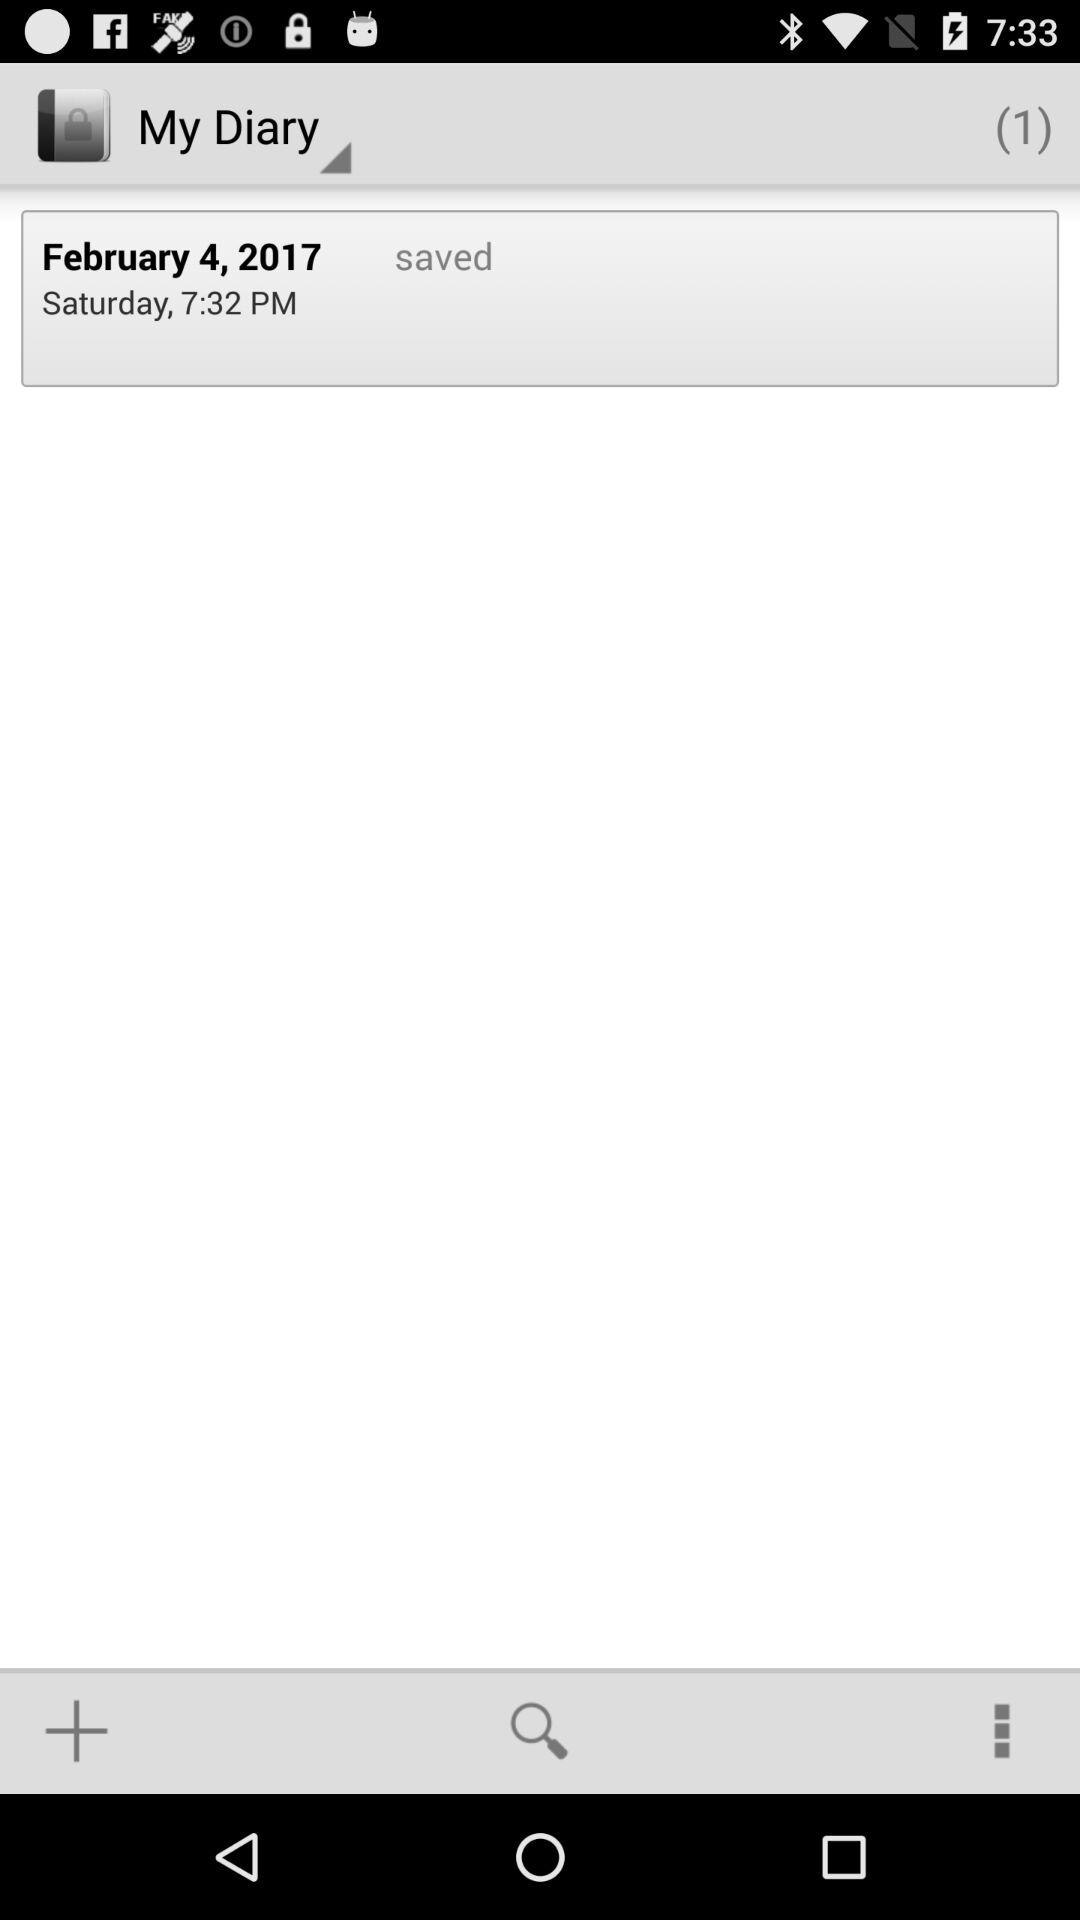What is the date? The date is February 4, 2017. 